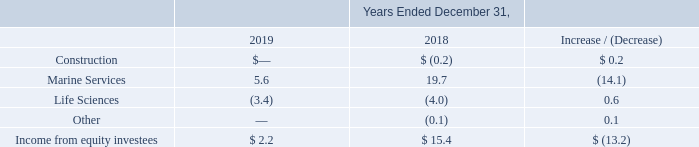Income from Equity Investees
Marine Services: Income from equity investees within our Marine Services segment for the year ended December 31, 2019 decreased $14.1 million to $5.6 million from $19.7 million for the year ended year ended December 31, 2018. The decrease was driven by HMN, due to lower revenues on large turnkey projects underway than in the comparable period.
The equity investment in HMN has contributed $5.0 million and $12.7 million in income from equity investees for the years ended December 31, 2019 and 2018, respectively. Further contributing to the reduction in income were losses at SBSS from a loss contingency related to ongoing legal disputes and lower vessel utilization.
Life Sciences: Loss from equity investees within our Life Sciences segment for the year ended December 31, 2019 decreased $0.6 million to $3.4 million from $4.0 million for the year ended December 31, 2018. The decrease in losses were largely due to lower equity method losses recorded from our investment in MediBeacon due to the timing of clinical trials and revenue from a licensing agreement which did not occur in the comparable periods.
What was the decrease in the income from equity investees in December 2019? $14.1 million. The equity investment in HMN contributed what amount in income from equity investees in December 2019? $5.0 million. What was the loss from equity investees for the year ended December 2019? $3.4 million. What was the percentage increase / (decrease) in the marine services from 2018 to 2019?
Answer scale should be: percent. 5.6 / 19.7 - 1
Answer: -71.57. What is the average life sciences?
Answer scale should be: million. -(3.4 + 4.0) / 2
Answer: -3.7. What is the percentage increase / (decrease) in the income from equity investees from 2018 to 2019?
Answer scale should be: percent. 2.2 / 15.4 - 1
Answer: -85.71. 